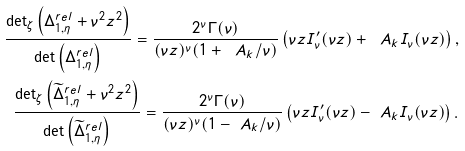Convert formula to latex. <formula><loc_0><loc_0><loc_500><loc_500>\frac { \det _ { \zeta } \left ( \Delta _ { 1 , \eta } ^ { r e l } + \nu ^ { 2 } z ^ { 2 } \right ) } { \det \left ( \Delta _ { 1 , \eta } ^ { r e l } \right ) } = \frac { 2 ^ { \nu } \Gamma ( \nu ) } { ( \nu z ) ^ { \nu } ( 1 + \ A _ { k } / \nu ) } \left ( \nu z I ^ { \prime } _ { \nu } ( \nu z ) + \ A _ { k } I _ { \nu } ( \nu z ) \right ) , \\ \frac { \det _ { \zeta } \left ( \widetilde { \Delta } _ { 1 , \eta } ^ { r e l } + \nu ^ { 2 } z ^ { 2 } \right ) } { \det \left ( \widetilde { \Delta } _ { 1 , \eta } ^ { r e l } \right ) } = \frac { 2 ^ { \nu } \Gamma ( \nu ) } { ( \nu z ) ^ { \nu } ( 1 - \ A _ { k } / \nu ) } \left ( \nu z I ^ { \prime } _ { \nu } ( \nu z ) - \ A _ { k } I _ { \nu } ( \nu z ) \right ) .</formula> 